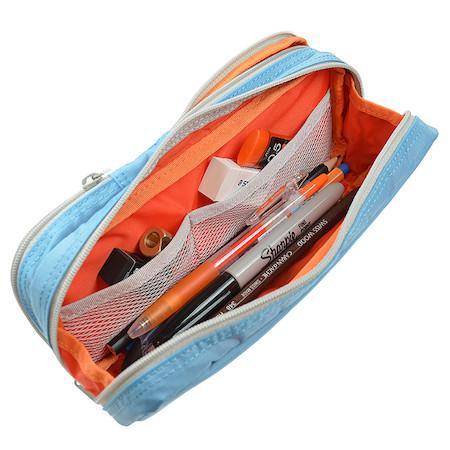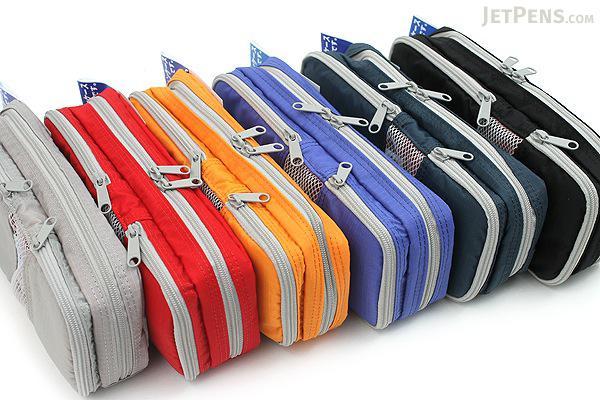The first image is the image on the left, the second image is the image on the right. Considering the images on both sides, is "An image shows one soft-sided case that is zipped shut." valid? Answer yes or no. No. The first image is the image on the left, the second image is the image on the right. Given the left and right images, does the statement "There is at least one pink pencil case." hold true? Answer yes or no. No. 